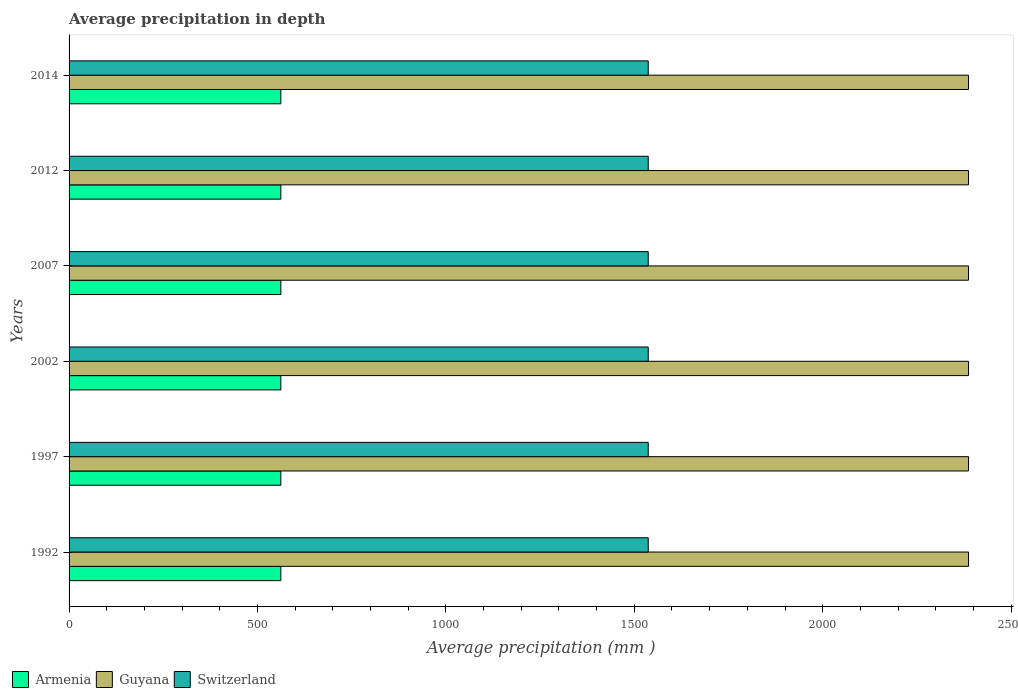How many different coloured bars are there?
Offer a very short reply. 3. What is the label of the 1st group of bars from the top?
Provide a short and direct response. 2014. In how many cases, is the number of bars for a given year not equal to the number of legend labels?
Your answer should be compact. 0. What is the average precipitation in Armenia in 1997?
Offer a very short reply. 562. Across all years, what is the maximum average precipitation in Armenia?
Give a very brief answer. 562. Across all years, what is the minimum average precipitation in Armenia?
Offer a very short reply. 562. In which year was the average precipitation in Guyana maximum?
Your answer should be very brief. 1992. In which year was the average precipitation in Switzerland minimum?
Your response must be concise. 1992. What is the total average precipitation in Guyana in the graph?
Your response must be concise. 1.43e+04. What is the difference between the average precipitation in Armenia in 1992 and that in 2007?
Keep it short and to the point. 0. What is the difference between the average precipitation in Armenia in 1992 and the average precipitation in Guyana in 2007?
Your answer should be very brief. -1825. What is the average average precipitation in Guyana per year?
Offer a very short reply. 2387. In the year 2002, what is the difference between the average precipitation in Switzerland and average precipitation in Armenia?
Your response must be concise. 975. Is the difference between the average precipitation in Switzerland in 1997 and 2007 greater than the difference between the average precipitation in Armenia in 1997 and 2007?
Your response must be concise. No. What is the difference between the highest and the lowest average precipitation in Switzerland?
Provide a succinct answer. 0. In how many years, is the average precipitation in Armenia greater than the average average precipitation in Armenia taken over all years?
Your answer should be very brief. 0. Is the sum of the average precipitation in Armenia in 1997 and 2012 greater than the maximum average precipitation in Guyana across all years?
Make the answer very short. No. What does the 3rd bar from the top in 1992 represents?
Offer a terse response. Armenia. What does the 3rd bar from the bottom in 2012 represents?
Keep it short and to the point. Switzerland. How many years are there in the graph?
Your answer should be compact. 6. Are the values on the major ticks of X-axis written in scientific E-notation?
Give a very brief answer. No. Does the graph contain any zero values?
Offer a very short reply. No. Where does the legend appear in the graph?
Provide a short and direct response. Bottom left. How many legend labels are there?
Provide a succinct answer. 3. How are the legend labels stacked?
Offer a terse response. Horizontal. What is the title of the graph?
Make the answer very short. Average precipitation in depth. Does "Togo" appear as one of the legend labels in the graph?
Make the answer very short. No. What is the label or title of the X-axis?
Keep it short and to the point. Average precipitation (mm ). What is the label or title of the Y-axis?
Provide a succinct answer. Years. What is the Average precipitation (mm ) of Armenia in 1992?
Make the answer very short. 562. What is the Average precipitation (mm ) of Guyana in 1992?
Offer a very short reply. 2387. What is the Average precipitation (mm ) of Switzerland in 1992?
Offer a very short reply. 1537. What is the Average precipitation (mm ) of Armenia in 1997?
Your answer should be compact. 562. What is the Average precipitation (mm ) of Guyana in 1997?
Ensure brevity in your answer.  2387. What is the Average precipitation (mm ) in Switzerland in 1997?
Your answer should be compact. 1537. What is the Average precipitation (mm ) in Armenia in 2002?
Your response must be concise. 562. What is the Average precipitation (mm ) in Guyana in 2002?
Offer a very short reply. 2387. What is the Average precipitation (mm ) in Switzerland in 2002?
Provide a short and direct response. 1537. What is the Average precipitation (mm ) of Armenia in 2007?
Offer a terse response. 562. What is the Average precipitation (mm ) in Guyana in 2007?
Your response must be concise. 2387. What is the Average precipitation (mm ) in Switzerland in 2007?
Give a very brief answer. 1537. What is the Average precipitation (mm ) in Armenia in 2012?
Offer a very short reply. 562. What is the Average precipitation (mm ) in Guyana in 2012?
Keep it short and to the point. 2387. What is the Average precipitation (mm ) of Switzerland in 2012?
Provide a short and direct response. 1537. What is the Average precipitation (mm ) in Armenia in 2014?
Offer a terse response. 562. What is the Average precipitation (mm ) of Guyana in 2014?
Make the answer very short. 2387. What is the Average precipitation (mm ) of Switzerland in 2014?
Give a very brief answer. 1537. Across all years, what is the maximum Average precipitation (mm ) in Armenia?
Keep it short and to the point. 562. Across all years, what is the maximum Average precipitation (mm ) of Guyana?
Your answer should be compact. 2387. Across all years, what is the maximum Average precipitation (mm ) of Switzerland?
Your answer should be compact. 1537. Across all years, what is the minimum Average precipitation (mm ) in Armenia?
Ensure brevity in your answer.  562. Across all years, what is the minimum Average precipitation (mm ) in Guyana?
Provide a succinct answer. 2387. Across all years, what is the minimum Average precipitation (mm ) in Switzerland?
Provide a short and direct response. 1537. What is the total Average precipitation (mm ) in Armenia in the graph?
Provide a succinct answer. 3372. What is the total Average precipitation (mm ) in Guyana in the graph?
Offer a very short reply. 1.43e+04. What is the total Average precipitation (mm ) of Switzerland in the graph?
Make the answer very short. 9222. What is the difference between the Average precipitation (mm ) in Switzerland in 1992 and that in 1997?
Give a very brief answer. 0. What is the difference between the Average precipitation (mm ) of Guyana in 1992 and that in 2002?
Keep it short and to the point. 0. What is the difference between the Average precipitation (mm ) of Switzerland in 1992 and that in 2002?
Offer a very short reply. 0. What is the difference between the Average precipitation (mm ) in Armenia in 1992 and that in 2007?
Your answer should be compact. 0. What is the difference between the Average precipitation (mm ) of Armenia in 1992 and that in 2012?
Provide a succinct answer. 0. What is the difference between the Average precipitation (mm ) in Guyana in 1992 and that in 2012?
Make the answer very short. 0. What is the difference between the Average precipitation (mm ) in Switzerland in 1992 and that in 2012?
Provide a short and direct response. 0. What is the difference between the Average precipitation (mm ) in Armenia in 1992 and that in 2014?
Your response must be concise. 0. What is the difference between the Average precipitation (mm ) of Armenia in 1997 and that in 2002?
Provide a succinct answer. 0. What is the difference between the Average precipitation (mm ) in Guyana in 1997 and that in 2002?
Your answer should be compact. 0. What is the difference between the Average precipitation (mm ) of Switzerland in 1997 and that in 2002?
Keep it short and to the point. 0. What is the difference between the Average precipitation (mm ) of Armenia in 1997 and that in 2007?
Your answer should be compact. 0. What is the difference between the Average precipitation (mm ) of Guyana in 1997 and that in 2007?
Give a very brief answer. 0. What is the difference between the Average precipitation (mm ) in Guyana in 1997 and that in 2014?
Make the answer very short. 0. What is the difference between the Average precipitation (mm ) of Switzerland in 1997 and that in 2014?
Make the answer very short. 0. What is the difference between the Average precipitation (mm ) in Armenia in 2002 and that in 2007?
Ensure brevity in your answer.  0. What is the difference between the Average precipitation (mm ) of Guyana in 2002 and that in 2007?
Your answer should be compact. 0. What is the difference between the Average precipitation (mm ) of Switzerland in 2002 and that in 2007?
Offer a very short reply. 0. What is the difference between the Average precipitation (mm ) in Guyana in 2002 and that in 2012?
Make the answer very short. 0. What is the difference between the Average precipitation (mm ) in Guyana in 2007 and that in 2012?
Your answer should be very brief. 0. What is the difference between the Average precipitation (mm ) in Switzerland in 2007 and that in 2012?
Your answer should be very brief. 0. What is the difference between the Average precipitation (mm ) of Guyana in 2007 and that in 2014?
Provide a short and direct response. 0. What is the difference between the Average precipitation (mm ) of Switzerland in 2007 and that in 2014?
Keep it short and to the point. 0. What is the difference between the Average precipitation (mm ) in Switzerland in 2012 and that in 2014?
Keep it short and to the point. 0. What is the difference between the Average precipitation (mm ) of Armenia in 1992 and the Average precipitation (mm ) of Guyana in 1997?
Your answer should be very brief. -1825. What is the difference between the Average precipitation (mm ) of Armenia in 1992 and the Average precipitation (mm ) of Switzerland in 1997?
Make the answer very short. -975. What is the difference between the Average precipitation (mm ) in Guyana in 1992 and the Average precipitation (mm ) in Switzerland in 1997?
Make the answer very short. 850. What is the difference between the Average precipitation (mm ) in Armenia in 1992 and the Average precipitation (mm ) in Guyana in 2002?
Give a very brief answer. -1825. What is the difference between the Average precipitation (mm ) in Armenia in 1992 and the Average precipitation (mm ) in Switzerland in 2002?
Your answer should be compact. -975. What is the difference between the Average precipitation (mm ) in Guyana in 1992 and the Average precipitation (mm ) in Switzerland in 2002?
Provide a succinct answer. 850. What is the difference between the Average precipitation (mm ) of Armenia in 1992 and the Average precipitation (mm ) of Guyana in 2007?
Give a very brief answer. -1825. What is the difference between the Average precipitation (mm ) of Armenia in 1992 and the Average precipitation (mm ) of Switzerland in 2007?
Offer a terse response. -975. What is the difference between the Average precipitation (mm ) in Guyana in 1992 and the Average precipitation (mm ) in Switzerland in 2007?
Your response must be concise. 850. What is the difference between the Average precipitation (mm ) in Armenia in 1992 and the Average precipitation (mm ) in Guyana in 2012?
Ensure brevity in your answer.  -1825. What is the difference between the Average precipitation (mm ) in Armenia in 1992 and the Average precipitation (mm ) in Switzerland in 2012?
Provide a short and direct response. -975. What is the difference between the Average precipitation (mm ) of Guyana in 1992 and the Average precipitation (mm ) of Switzerland in 2012?
Make the answer very short. 850. What is the difference between the Average precipitation (mm ) of Armenia in 1992 and the Average precipitation (mm ) of Guyana in 2014?
Offer a very short reply. -1825. What is the difference between the Average precipitation (mm ) of Armenia in 1992 and the Average precipitation (mm ) of Switzerland in 2014?
Offer a very short reply. -975. What is the difference between the Average precipitation (mm ) of Guyana in 1992 and the Average precipitation (mm ) of Switzerland in 2014?
Give a very brief answer. 850. What is the difference between the Average precipitation (mm ) of Armenia in 1997 and the Average precipitation (mm ) of Guyana in 2002?
Your answer should be compact. -1825. What is the difference between the Average precipitation (mm ) of Armenia in 1997 and the Average precipitation (mm ) of Switzerland in 2002?
Your answer should be compact. -975. What is the difference between the Average precipitation (mm ) of Guyana in 1997 and the Average precipitation (mm ) of Switzerland in 2002?
Keep it short and to the point. 850. What is the difference between the Average precipitation (mm ) in Armenia in 1997 and the Average precipitation (mm ) in Guyana in 2007?
Offer a terse response. -1825. What is the difference between the Average precipitation (mm ) in Armenia in 1997 and the Average precipitation (mm ) in Switzerland in 2007?
Your answer should be compact. -975. What is the difference between the Average precipitation (mm ) in Guyana in 1997 and the Average precipitation (mm ) in Switzerland in 2007?
Provide a short and direct response. 850. What is the difference between the Average precipitation (mm ) in Armenia in 1997 and the Average precipitation (mm ) in Guyana in 2012?
Offer a terse response. -1825. What is the difference between the Average precipitation (mm ) in Armenia in 1997 and the Average precipitation (mm ) in Switzerland in 2012?
Provide a short and direct response. -975. What is the difference between the Average precipitation (mm ) of Guyana in 1997 and the Average precipitation (mm ) of Switzerland in 2012?
Provide a succinct answer. 850. What is the difference between the Average precipitation (mm ) of Armenia in 1997 and the Average precipitation (mm ) of Guyana in 2014?
Your response must be concise. -1825. What is the difference between the Average precipitation (mm ) in Armenia in 1997 and the Average precipitation (mm ) in Switzerland in 2014?
Provide a succinct answer. -975. What is the difference between the Average precipitation (mm ) in Guyana in 1997 and the Average precipitation (mm ) in Switzerland in 2014?
Offer a terse response. 850. What is the difference between the Average precipitation (mm ) of Armenia in 2002 and the Average precipitation (mm ) of Guyana in 2007?
Ensure brevity in your answer.  -1825. What is the difference between the Average precipitation (mm ) of Armenia in 2002 and the Average precipitation (mm ) of Switzerland in 2007?
Offer a very short reply. -975. What is the difference between the Average precipitation (mm ) of Guyana in 2002 and the Average precipitation (mm ) of Switzerland in 2007?
Offer a very short reply. 850. What is the difference between the Average precipitation (mm ) in Armenia in 2002 and the Average precipitation (mm ) in Guyana in 2012?
Your response must be concise. -1825. What is the difference between the Average precipitation (mm ) in Armenia in 2002 and the Average precipitation (mm ) in Switzerland in 2012?
Give a very brief answer. -975. What is the difference between the Average precipitation (mm ) of Guyana in 2002 and the Average precipitation (mm ) of Switzerland in 2012?
Offer a very short reply. 850. What is the difference between the Average precipitation (mm ) of Armenia in 2002 and the Average precipitation (mm ) of Guyana in 2014?
Offer a very short reply. -1825. What is the difference between the Average precipitation (mm ) in Armenia in 2002 and the Average precipitation (mm ) in Switzerland in 2014?
Your answer should be compact. -975. What is the difference between the Average precipitation (mm ) in Guyana in 2002 and the Average precipitation (mm ) in Switzerland in 2014?
Offer a terse response. 850. What is the difference between the Average precipitation (mm ) of Armenia in 2007 and the Average precipitation (mm ) of Guyana in 2012?
Provide a short and direct response. -1825. What is the difference between the Average precipitation (mm ) in Armenia in 2007 and the Average precipitation (mm ) in Switzerland in 2012?
Provide a succinct answer. -975. What is the difference between the Average precipitation (mm ) of Guyana in 2007 and the Average precipitation (mm ) of Switzerland in 2012?
Provide a succinct answer. 850. What is the difference between the Average precipitation (mm ) of Armenia in 2007 and the Average precipitation (mm ) of Guyana in 2014?
Your answer should be compact. -1825. What is the difference between the Average precipitation (mm ) in Armenia in 2007 and the Average precipitation (mm ) in Switzerland in 2014?
Make the answer very short. -975. What is the difference between the Average precipitation (mm ) of Guyana in 2007 and the Average precipitation (mm ) of Switzerland in 2014?
Keep it short and to the point. 850. What is the difference between the Average precipitation (mm ) of Armenia in 2012 and the Average precipitation (mm ) of Guyana in 2014?
Provide a succinct answer. -1825. What is the difference between the Average precipitation (mm ) of Armenia in 2012 and the Average precipitation (mm ) of Switzerland in 2014?
Offer a terse response. -975. What is the difference between the Average precipitation (mm ) in Guyana in 2012 and the Average precipitation (mm ) in Switzerland in 2014?
Offer a terse response. 850. What is the average Average precipitation (mm ) of Armenia per year?
Offer a terse response. 562. What is the average Average precipitation (mm ) of Guyana per year?
Provide a succinct answer. 2387. What is the average Average precipitation (mm ) of Switzerland per year?
Provide a succinct answer. 1537. In the year 1992, what is the difference between the Average precipitation (mm ) of Armenia and Average precipitation (mm ) of Guyana?
Ensure brevity in your answer.  -1825. In the year 1992, what is the difference between the Average precipitation (mm ) of Armenia and Average precipitation (mm ) of Switzerland?
Your answer should be very brief. -975. In the year 1992, what is the difference between the Average precipitation (mm ) of Guyana and Average precipitation (mm ) of Switzerland?
Provide a short and direct response. 850. In the year 1997, what is the difference between the Average precipitation (mm ) in Armenia and Average precipitation (mm ) in Guyana?
Your answer should be compact. -1825. In the year 1997, what is the difference between the Average precipitation (mm ) in Armenia and Average precipitation (mm ) in Switzerland?
Offer a terse response. -975. In the year 1997, what is the difference between the Average precipitation (mm ) in Guyana and Average precipitation (mm ) in Switzerland?
Give a very brief answer. 850. In the year 2002, what is the difference between the Average precipitation (mm ) in Armenia and Average precipitation (mm ) in Guyana?
Your answer should be very brief. -1825. In the year 2002, what is the difference between the Average precipitation (mm ) of Armenia and Average precipitation (mm ) of Switzerland?
Keep it short and to the point. -975. In the year 2002, what is the difference between the Average precipitation (mm ) in Guyana and Average precipitation (mm ) in Switzerland?
Your response must be concise. 850. In the year 2007, what is the difference between the Average precipitation (mm ) of Armenia and Average precipitation (mm ) of Guyana?
Provide a short and direct response. -1825. In the year 2007, what is the difference between the Average precipitation (mm ) of Armenia and Average precipitation (mm ) of Switzerland?
Your response must be concise. -975. In the year 2007, what is the difference between the Average precipitation (mm ) of Guyana and Average precipitation (mm ) of Switzerland?
Provide a succinct answer. 850. In the year 2012, what is the difference between the Average precipitation (mm ) of Armenia and Average precipitation (mm ) of Guyana?
Your response must be concise. -1825. In the year 2012, what is the difference between the Average precipitation (mm ) of Armenia and Average precipitation (mm ) of Switzerland?
Keep it short and to the point. -975. In the year 2012, what is the difference between the Average precipitation (mm ) in Guyana and Average precipitation (mm ) in Switzerland?
Your response must be concise. 850. In the year 2014, what is the difference between the Average precipitation (mm ) in Armenia and Average precipitation (mm ) in Guyana?
Offer a very short reply. -1825. In the year 2014, what is the difference between the Average precipitation (mm ) of Armenia and Average precipitation (mm ) of Switzerland?
Ensure brevity in your answer.  -975. In the year 2014, what is the difference between the Average precipitation (mm ) in Guyana and Average precipitation (mm ) in Switzerland?
Your response must be concise. 850. What is the ratio of the Average precipitation (mm ) in Switzerland in 1992 to that in 1997?
Your answer should be compact. 1. What is the ratio of the Average precipitation (mm ) of Switzerland in 1992 to that in 2002?
Ensure brevity in your answer.  1. What is the ratio of the Average precipitation (mm ) of Guyana in 1992 to that in 2007?
Give a very brief answer. 1. What is the ratio of the Average precipitation (mm ) of Armenia in 1992 to that in 2012?
Provide a short and direct response. 1. What is the ratio of the Average precipitation (mm ) in Guyana in 1992 to that in 2012?
Your response must be concise. 1. What is the ratio of the Average precipitation (mm ) of Switzerland in 1992 to that in 2012?
Keep it short and to the point. 1. What is the ratio of the Average precipitation (mm ) in Armenia in 1992 to that in 2014?
Ensure brevity in your answer.  1. What is the ratio of the Average precipitation (mm ) in Switzerland in 1992 to that in 2014?
Provide a succinct answer. 1. What is the ratio of the Average precipitation (mm ) in Guyana in 1997 to that in 2007?
Give a very brief answer. 1. What is the ratio of the Average precipitation (mm ) of Switzerland in 1997 to that in 2007?
Your response must be concise. 1. What is the ratio of the Average precipitation (mm ) in Guyana in 1997 to that in 2012?
Ensure brevity in your answer.  1. What is the ratio of the Average precipitation (mm ) in Switzerland in 1997 to that in 2012?
Offer a very short reply. 1. What is the ratio of the Average precipitation (mm ) of Switzerland in 2002 to that in 2007?
Your answer should be compact. 1. What is the ratio of the Average precipitation (mm ) in Switzerland in 2002 to that in 2012?
Your answer should be very brief. 1. What is the ratio of the Average precipitation (mm ) of Guyana in 2007 to that in 2012?
Your response must be concise. 1. What is the ratio of the Average precipitation (mm ) in Switzerland in 2007 to that in 2012?
Offer a very short reply. 1. What is the ratio of the Average precipitation (mm ) of Armenia in 2007 to that in 2014?
Provide a succinct answer. 1. What is the ratio of the Average precipitation (mm ) in Armenia in 2012 to that in 2014?
Your answer should be compact. 1. What is the difference between the highest and the lowest Average precipitation (mm ) of Guyana?
Provide a short and direct response. 0. 